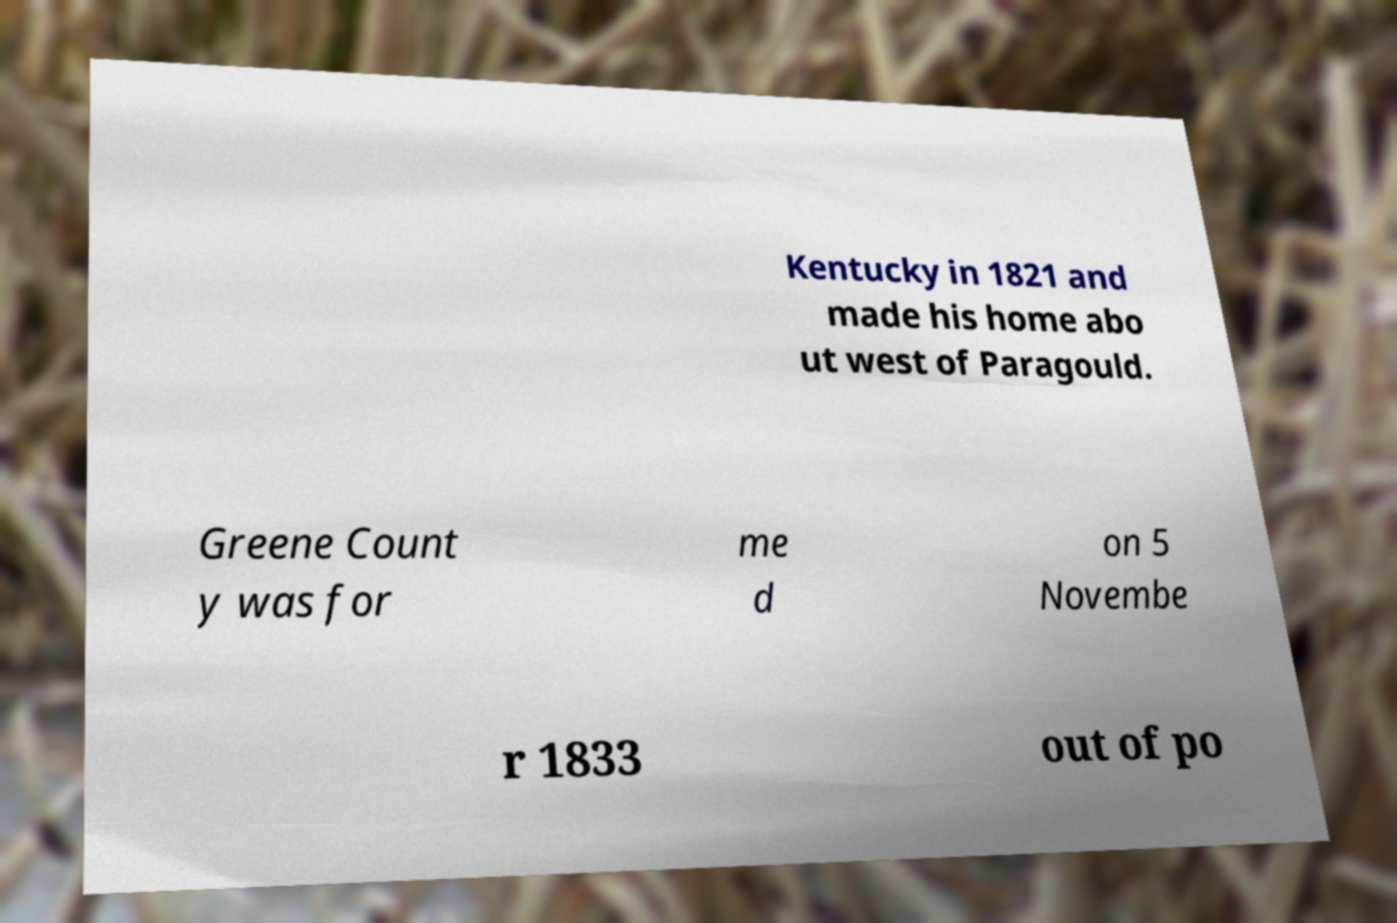What messages or text are displayed in this image? I need them in a readable, typed format. Kentucky in 1821 and made his home abo ut west of Paragould. Greene Count y was for me d on 5 Novembe r 1833 out of po 